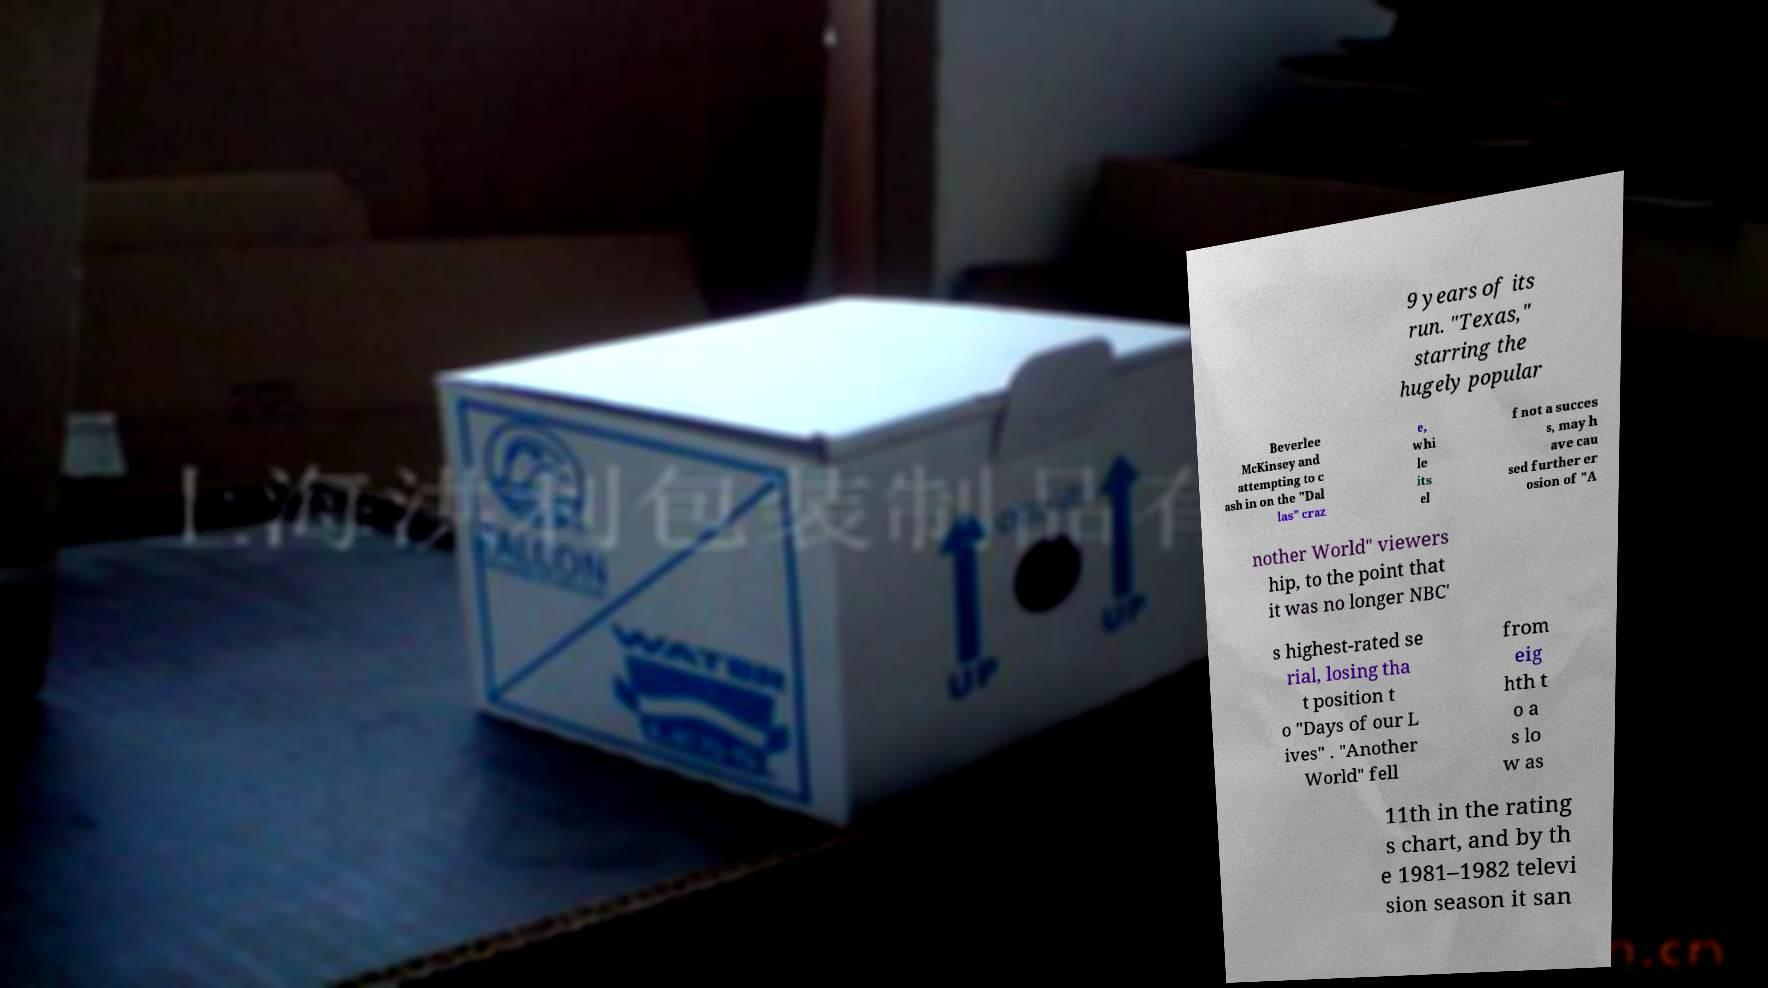I need the written content from this picture converted into text. Can you do that? 9 years of its run. "Texas," starring the hugely popular Beverlee McKinsey and attempting to c ash in on the "Dal las" craz e, whi le its el f not a succes s, may h ave cau sed further er osion of "A nother World" viewers hip, to the point that it was no longer NBC' s highest-rated se rial, losing tha t position t o "Days of our L ives" . "Another World" fell from eig hth t o a s lo w as 11th in the rating s chart, and by th e 1981–1982 televi sion season it san 